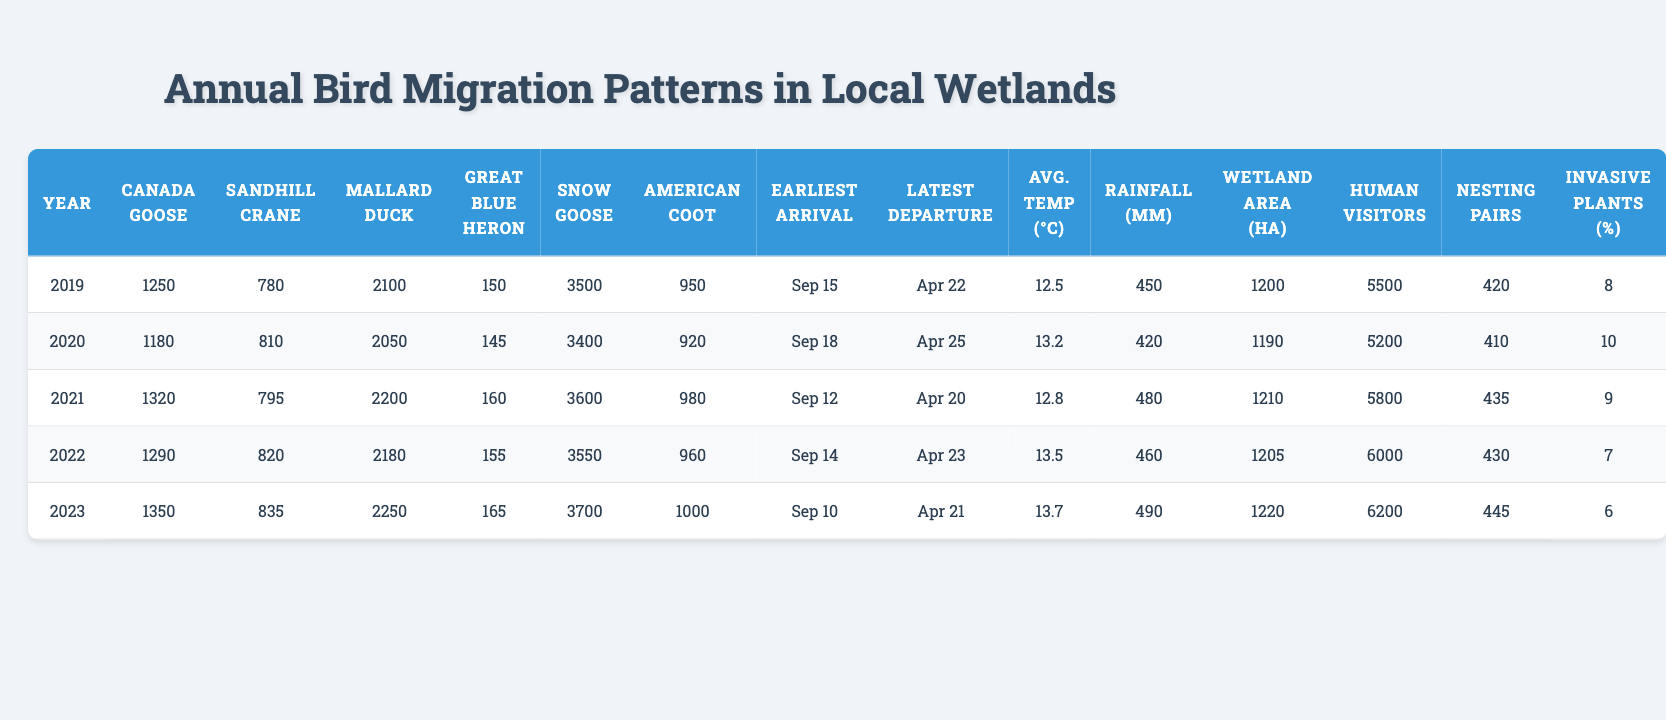What was the highest count of Canada Geese observed in the last 5 years? The table shows the counts of Canada Geese from the years 2019 to 2023. The counts are 1250, 1180, 1320, 1290, and 1350. The highest value among these is 1350 in 2023.
Answer: 1350 What year had the lowest count of Sandhill Cranes? The counts of Sandhill Cranes are provided for each year: 780, 810, 795, 820, and 835. The lowest count is 780, which occurred in 2019.
Answer: 2019 How many more Mallard Ducks were observed in 2023 compared to 2019? The counts of Mallard Ducks for 2019 and 2023 are 2100 and 2250 respectively. To find the difference, subtract 2100 from 2250, which gives 2250 - 2100 = 150 more Mallard Ducks in 2023.
Answer: 150 Did the average temperature increase from 2019 to 2023? The average temperatures for 2019 and 2023 are 12.5°C and 13.7°C respectively. Since 13.7°C is greater than 12.5°C, we confirm that the average temperature did increase from 2019 to 2023.
Answer: Yes What was the average number of American Coots counted over the 5 years? The counts for American Coots from 2019 to 2023 are 950, 920, 980, 960, and 1000. To find the average, we sum these values: 950 + 920 + 980 + 960 + 1000 = 4810. Then, we divide by 5 for the average: 4810 / 5 = 962.
Answer: 962 In which year was rainfall the highest, and how much was it? The rainfall amounts for the years are 450mm, 420mm, 480mm, 460mm, and 490mm respectively from 2019 to 2023. The highest amount is 490mm in 2023.
Answer: 2023, 490mm What was the change in the number of Human Visitors from 2019 to 2023? The number of Human Visitors increased from 5500 in 2019 to 6200 in 2023. The change is calculated by subtracting the 2019 count from the 2023 count: 6200 - 5500 = 700.
Answer: 700 Is the total count of Snow Geese greater than the total count of Great Blue Herons across the 5 years? The counts of Snow Geese are 3500, 3400, 3600, 3550, and 3700 (total = 17550), while Great Blue Herons are 150, 145, 160, 155, and 165 (total = 775). Since 17550 is greater than 775, the statement is true.
Answer: Yes What is the median number of nesting pairs observed over the last 5 years? The counts of Nesting Pairs are 420, 410, 435, 430, and 445. When ordered, these become 410, 420, 430, 435, and 445. The median, which is the middle value in a sorted list of 5 numbers, is 430.
Answer: 430 How has the cover of invasive plant species changed from 2019 to 2023? The invasive plant species cover percentages are 8%, 10%, 9%, 7%, and 6% from 2019 to 2023. Observing these values, we can see a decrease from 8% to 6% over the years, indicating improvement.
Answer: Decreased 